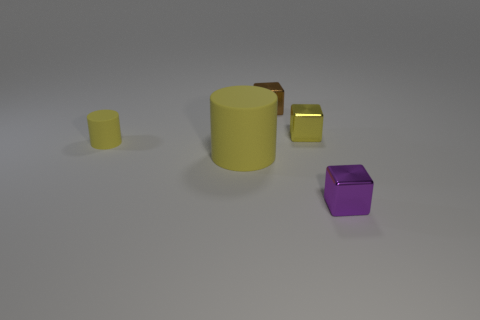Add 2 large cylinders. How many objects exist? 7 Subtract all cubes. How many objects are left? 2 Subtract all cyan cylinders. Subtract all purple metal objects. How many objects are left? 4 Add 4 tiny brown metal things. How many tiny brown metal things are left? 5 Add 2 tiny brown metal objects. How many tiny brown metal objects exist? 3 Subtract 1 purple blocks. How many objects are left? 4 